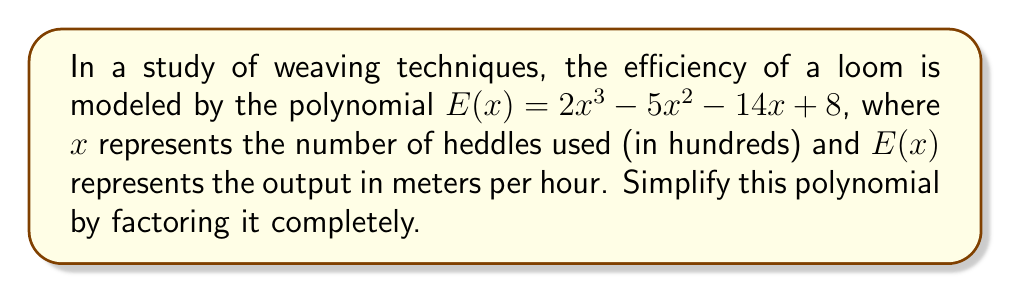Teach me how to tackle this problem. To factor this polynomial completely, we'll follow these steps:

1) First, let's check if there's a common factor:
   $E(x) = 2x^3 - 5x^2 - 14x + 8$
   There's no common factor for all terms.

2) Next, let's try the rational root theorem to find potential roots. The factors of the constant term (8) are: ±1, ±2, ±4, ±8.

3) Testing these values, we find that $x = 2$ is a root. So $(x - 2)$ is a factor.

4) Divide $E(x)$ by $(x - 2)$:

   $$\begin{array}{r}
   2x^2 + 1x - 4 \\
   x - 2 \enclose{longdiv}{2x^3 - 5x^2 - 14x + 8} \\
   \underline{2x^3 - 4x^2} \\
   -x^2 - 14x \\
   \underline{-x^2 + 2x} \\
   -16x + 8 \\
   \underline{-16x + 32} \\
   -24
   \end{array}$$

5) So, $E(x) = (x - 2)(2x^2 + x - 4)$

6) Now, let's factor the quadratic term $2x^2 + x - 4$:
   
   a) First, multiply by the leading coefficient: $2(2x^2 + x - 4) = 4x^2 + 2x - 8$
   
   b) Find two numbers that multiply to give $4 \cdot (-8) = -32$ and add to give 2:
      These numbers are 8 and -6
   
   c) Rewrite the middle term: $4x^2 + 8x - 6x - 8$
   
   d) Factor by grouping: $(4x^2 + 8x) + (-6x - 8)$
                          $4x(x + 2) - 2(3x + 4)$
                          $2(2x(x + 2) - (3x + 4))$
                          $2((2x + 1)(x + 2) - 2)$
                          $2(2x + 1)(x + 2) - 4$

7) Therefore, the fully factored polynomial is:

   $E(x) = (x - 2)(2x + 1)(x + 2)$
Answer: $(x - 2)(2x + 1)(x + 2)$ 